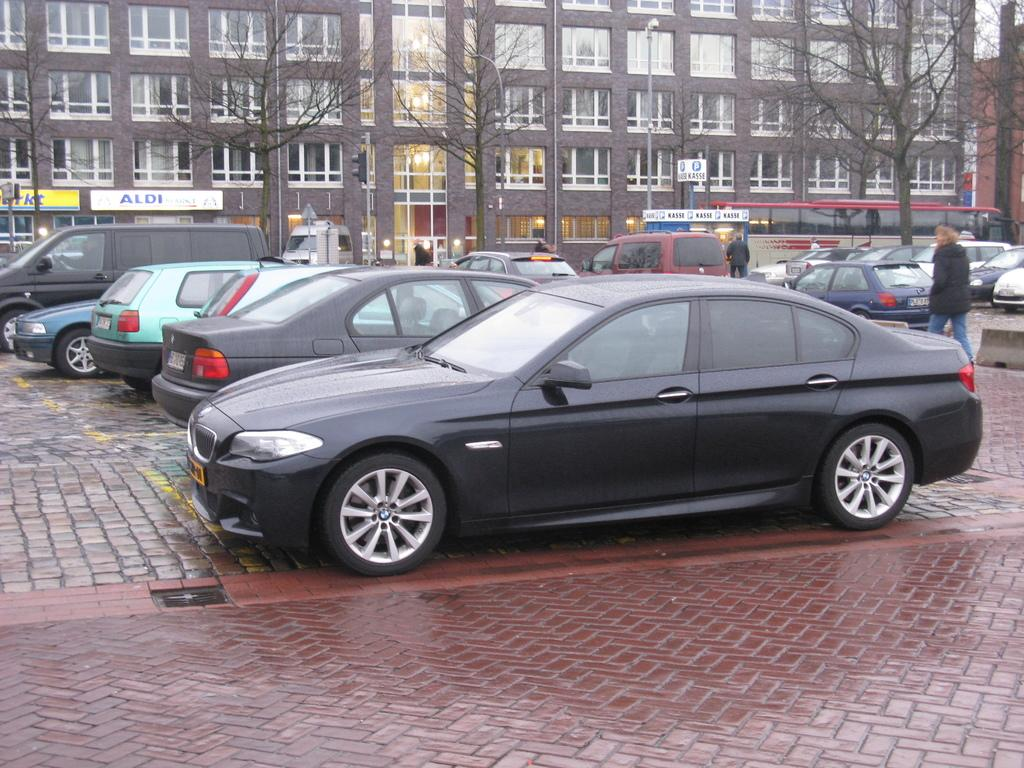What types of objects are present in the image? There are vehicles and persons in the image. What can be seen in the background of the image? There is a building, trees, a light on a pole, and windows in the background of the image. What type of head can be seen on the vehicles in the image? There are no heads present on the vehicles in the image; they are inanimate objects. 